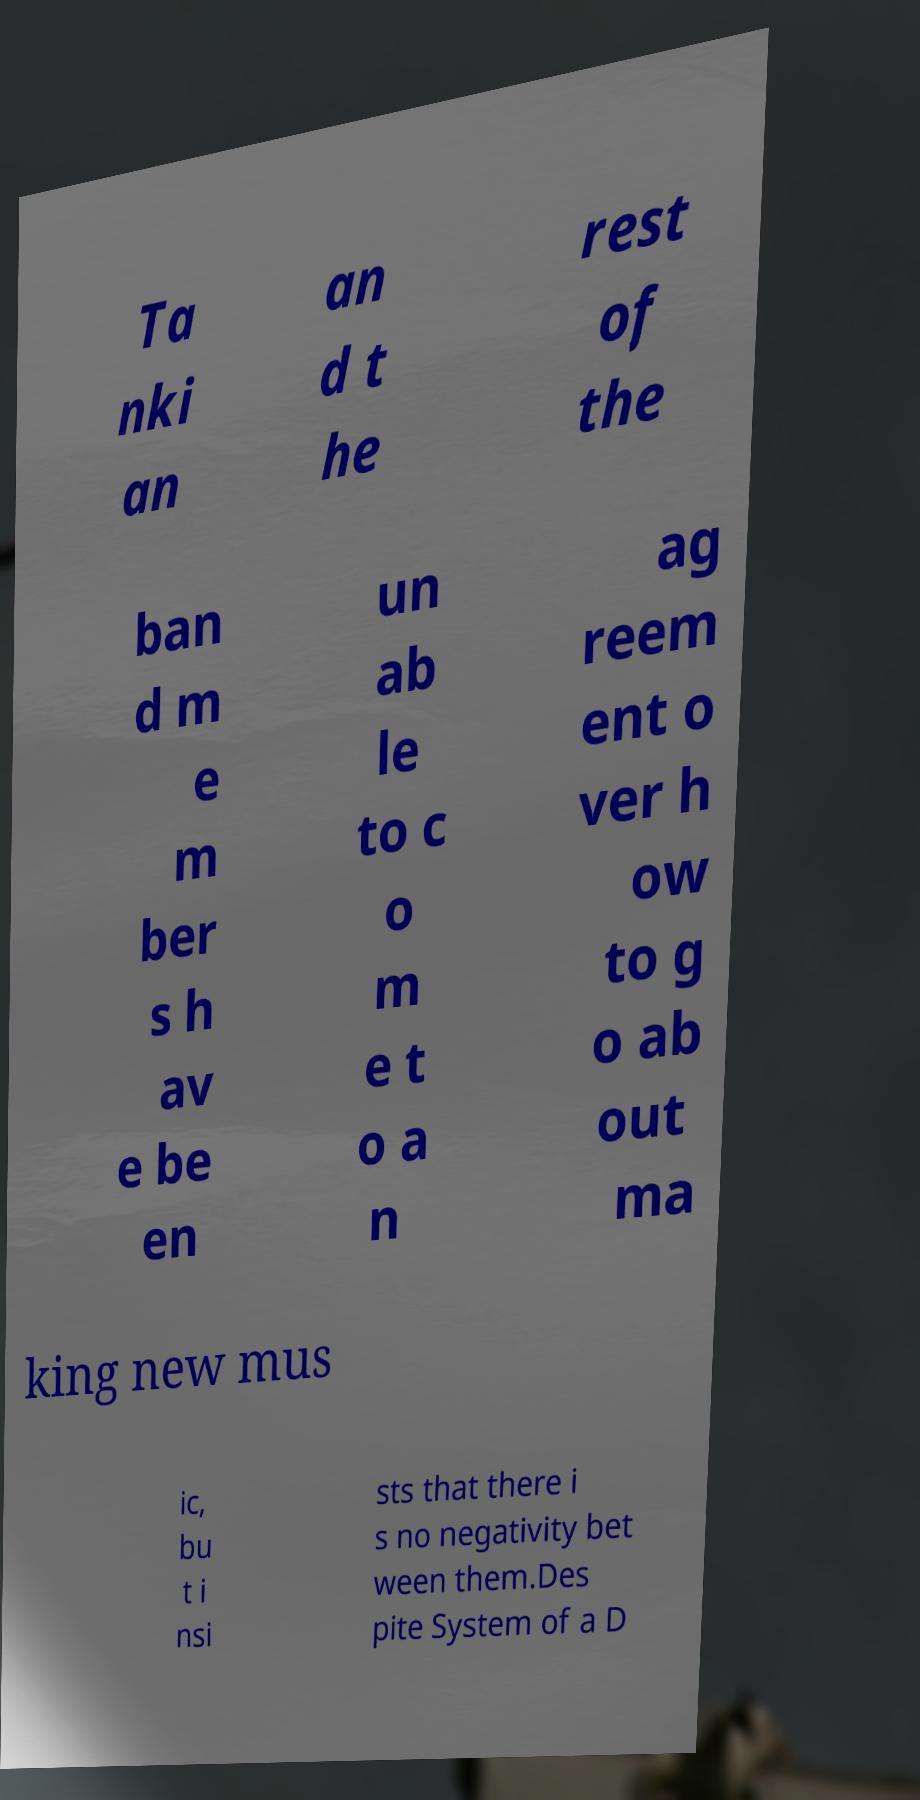There's text embedded in this image that I need extracted. Can you transcribe it verbatim? Ta nki an an d t he rest of the ban d m e m ber s h av e be en un ab le to c o m e t o a n ag reem ent o ver h ow to g o ab out ma king new mus ic, bu t i nsi sts that there i s no negativity bet ween them.Des pite System of a D 